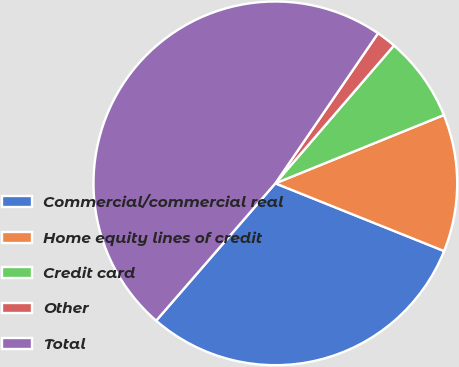Convert chart. <chart><loc_0><loc_0><loc_500><loc_500><pie_chart><fcel>Commercial/commercial real<fcel>Home equity lines of credit<fcel>Credit card<fcel>Other<fcel>Total<nl><fcel>30.3%<fcel>12.2%<fcel>7.56%<fcel>1.76%<fcel>48.17%<nl></chart> 